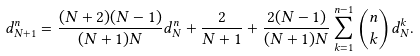<formula> <loc_0><loc_0><loc_500><loc_500>d _ { N + 1 } ^ { n } = \frac { ( N + 2 ) ( N - 1 ) } { ( N + 1 ) N } d _ { N } ^ { n } + \frac { 2 } { N + 1 } + \frac { 2 ( N - 1 ) } { ( N + 1 ) N } \sum _ { k = 1 } ^ { n - 1 } { n \choose k } d _ { N } ^ { k } .</formula> 